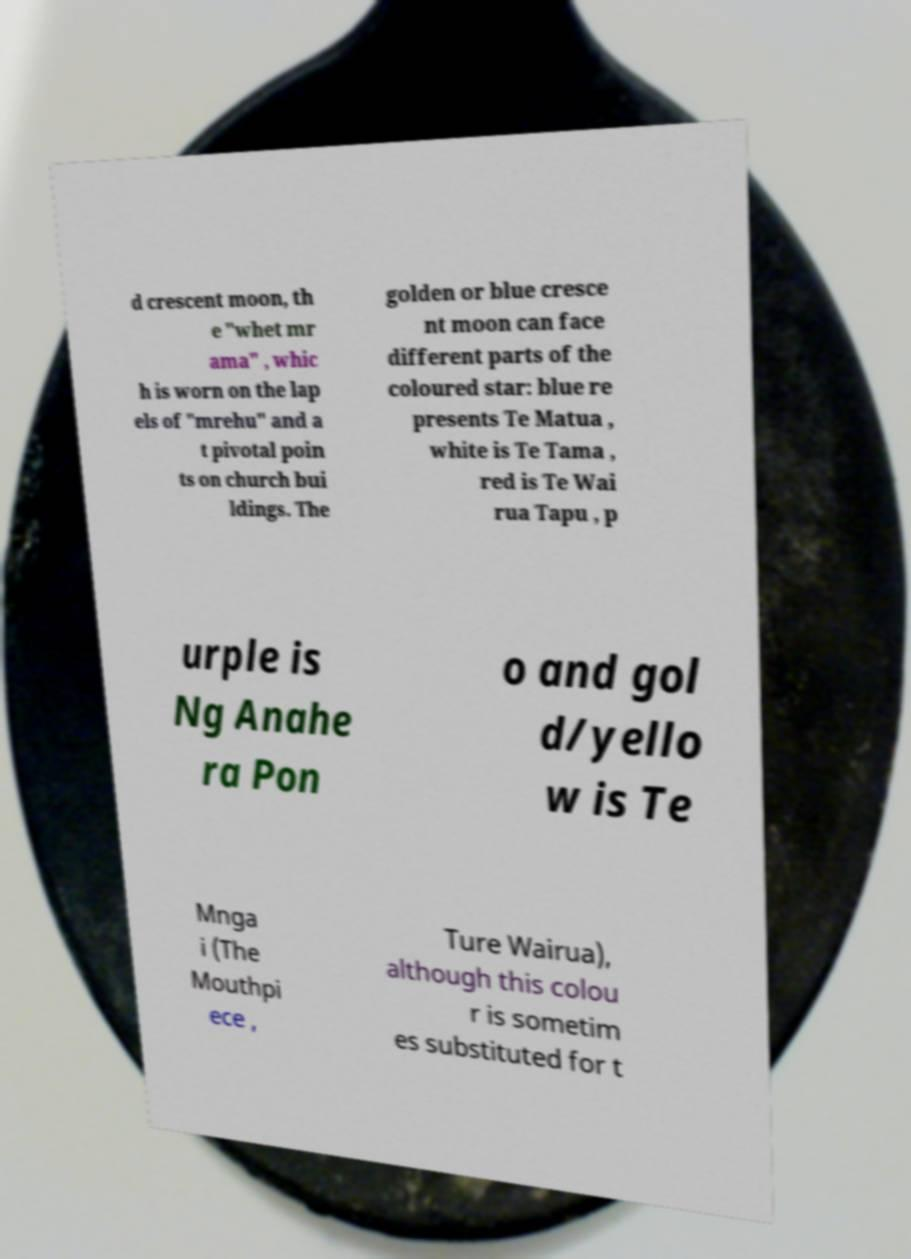For documentation purposes, I need the text within this image transcribed. Could you provide that? d crescent moon, th e "whet mr ama" , whic h is worn on the lap els of "mrehu" and a t pivotal poin ts on church bui ldings. The golden or blue cresce nt moon can face different parts of the coloured star: blue re presents Te Matua , white is Te Tama , red is Te Wai rua Tapu , p urple is Ng Anahe ra Pon o and gol d/yello w is Te Mnga i (The Mouthpi ece , Ture Wairua), although this colou r is sometim es substituted for t 